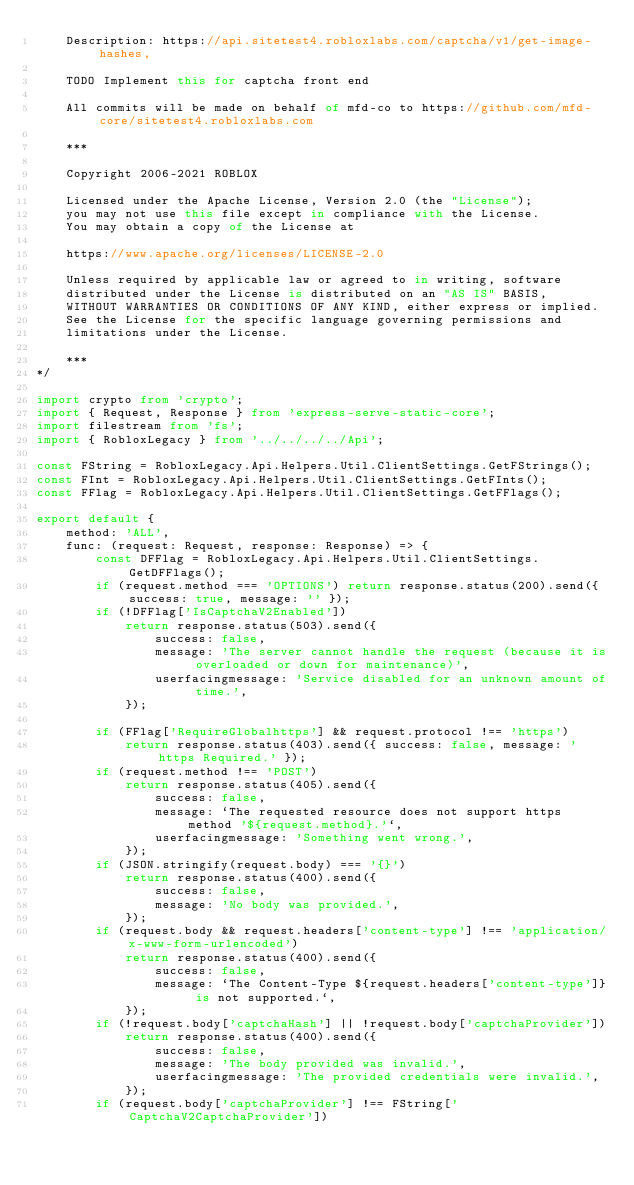Convert code to text. <code><loc_0><loc_0><loc_500><loc_500><_TypeScript_>	Description: https://api.sitetest4.robloxlabs.com/captcha/v1/get-image-hashes,

	TODO Implement this for captcha front end

	All commits will be made on behalf of mfd-co to https://github.com/mfd-core/sitetest4.robloxlabs.com

	***

	Copyright 2006-2021 ROBLOX

	Licensed under the Apache License, Version 2.0 (the "License");
	you may not use this file except in compliance with the License.
	You may obtain a copy of the License at

	https://www.apache.org/licenses/LICENSE-2.0

	Unless required by applicable law or agreed to in writing, software
	distributed under the License is distributed on an "AS IS" BASIS,
	WITHOUT WARRANTIES OR CONDITIONS OF ANY KIND, either express or implied.
	See the License for the specific language governing permissions and
	limitations under the License.

	***
*/

import crypto from 'crypto';
import { Request, Response } from 'express-serve-static-core';
import filestream from 'fs';
import { RobloxLegacy } from '../../../../Api';

const FString = RobloxLegacy.Api.Helpers.Util.ClientSettings.GetFStrings();
const FInt = RobloxLegacy.Api.Helpers.Util.ClientSettings.GetFInts();
const FFlag = RobloxLegacy.Api.Helpers.Util.ClientSettings.GetFFlags();

export default {
	method: 'ALL',
	func: (request: Request, response: Response) => {
		const DFFlag = RobloxLegacy.Api.Helpers.Util.ClientSettings.GetDFFlags();
		if (request.method === 'OPTIONS') return response.status(200).send({ success: true, message: '' });
		if (!DFFlag['IsCaptchaV2Enabled'])
			return response.status(503).send({
				success: false,
				message: 'The server cannot handle the request (because it is overloaded or down for maintenance)',
				userfacingmessage: 'Service disabled for an unknown amount of time.',
			});

		if (FFlag['RequireGlobalhttps'] && request.protocol !== 'https')
			return response.status(403).send({ success: false, message: 'https Required.' });
		if (request.method !== 'POST')
			return response.status(405).send({
				success: false,
				message: `The requested resource does not support https method '${request.method}.'`,
				userfacingmessage: 'Something went wrong.',
			});
		if (JSON.stringify(request.body) === '{}')
			return response.status(400).send({
				success: false,
				message: 'No body was provided.',
			});
		if (request.body && request.headers['content-type'] !== 'application/x-www-form-urlencoded')
			return response.status(400).send({
				success: false,
				message: `The Content-Type ${request.headers['content-type']} is not supported.`,
			});
		if (!request.body['captchaHash'] || !request.body['captchaProvider'])
			return response.status(400).send({
				success: false,
				message: 'The body provided was invalid.',
				userfacingmessage: 'The provided credentials were invalid.',
			});
		if (request.body['captchaProvider'] !== FString['CaptchaV2CaptchaProvider'])</code> 